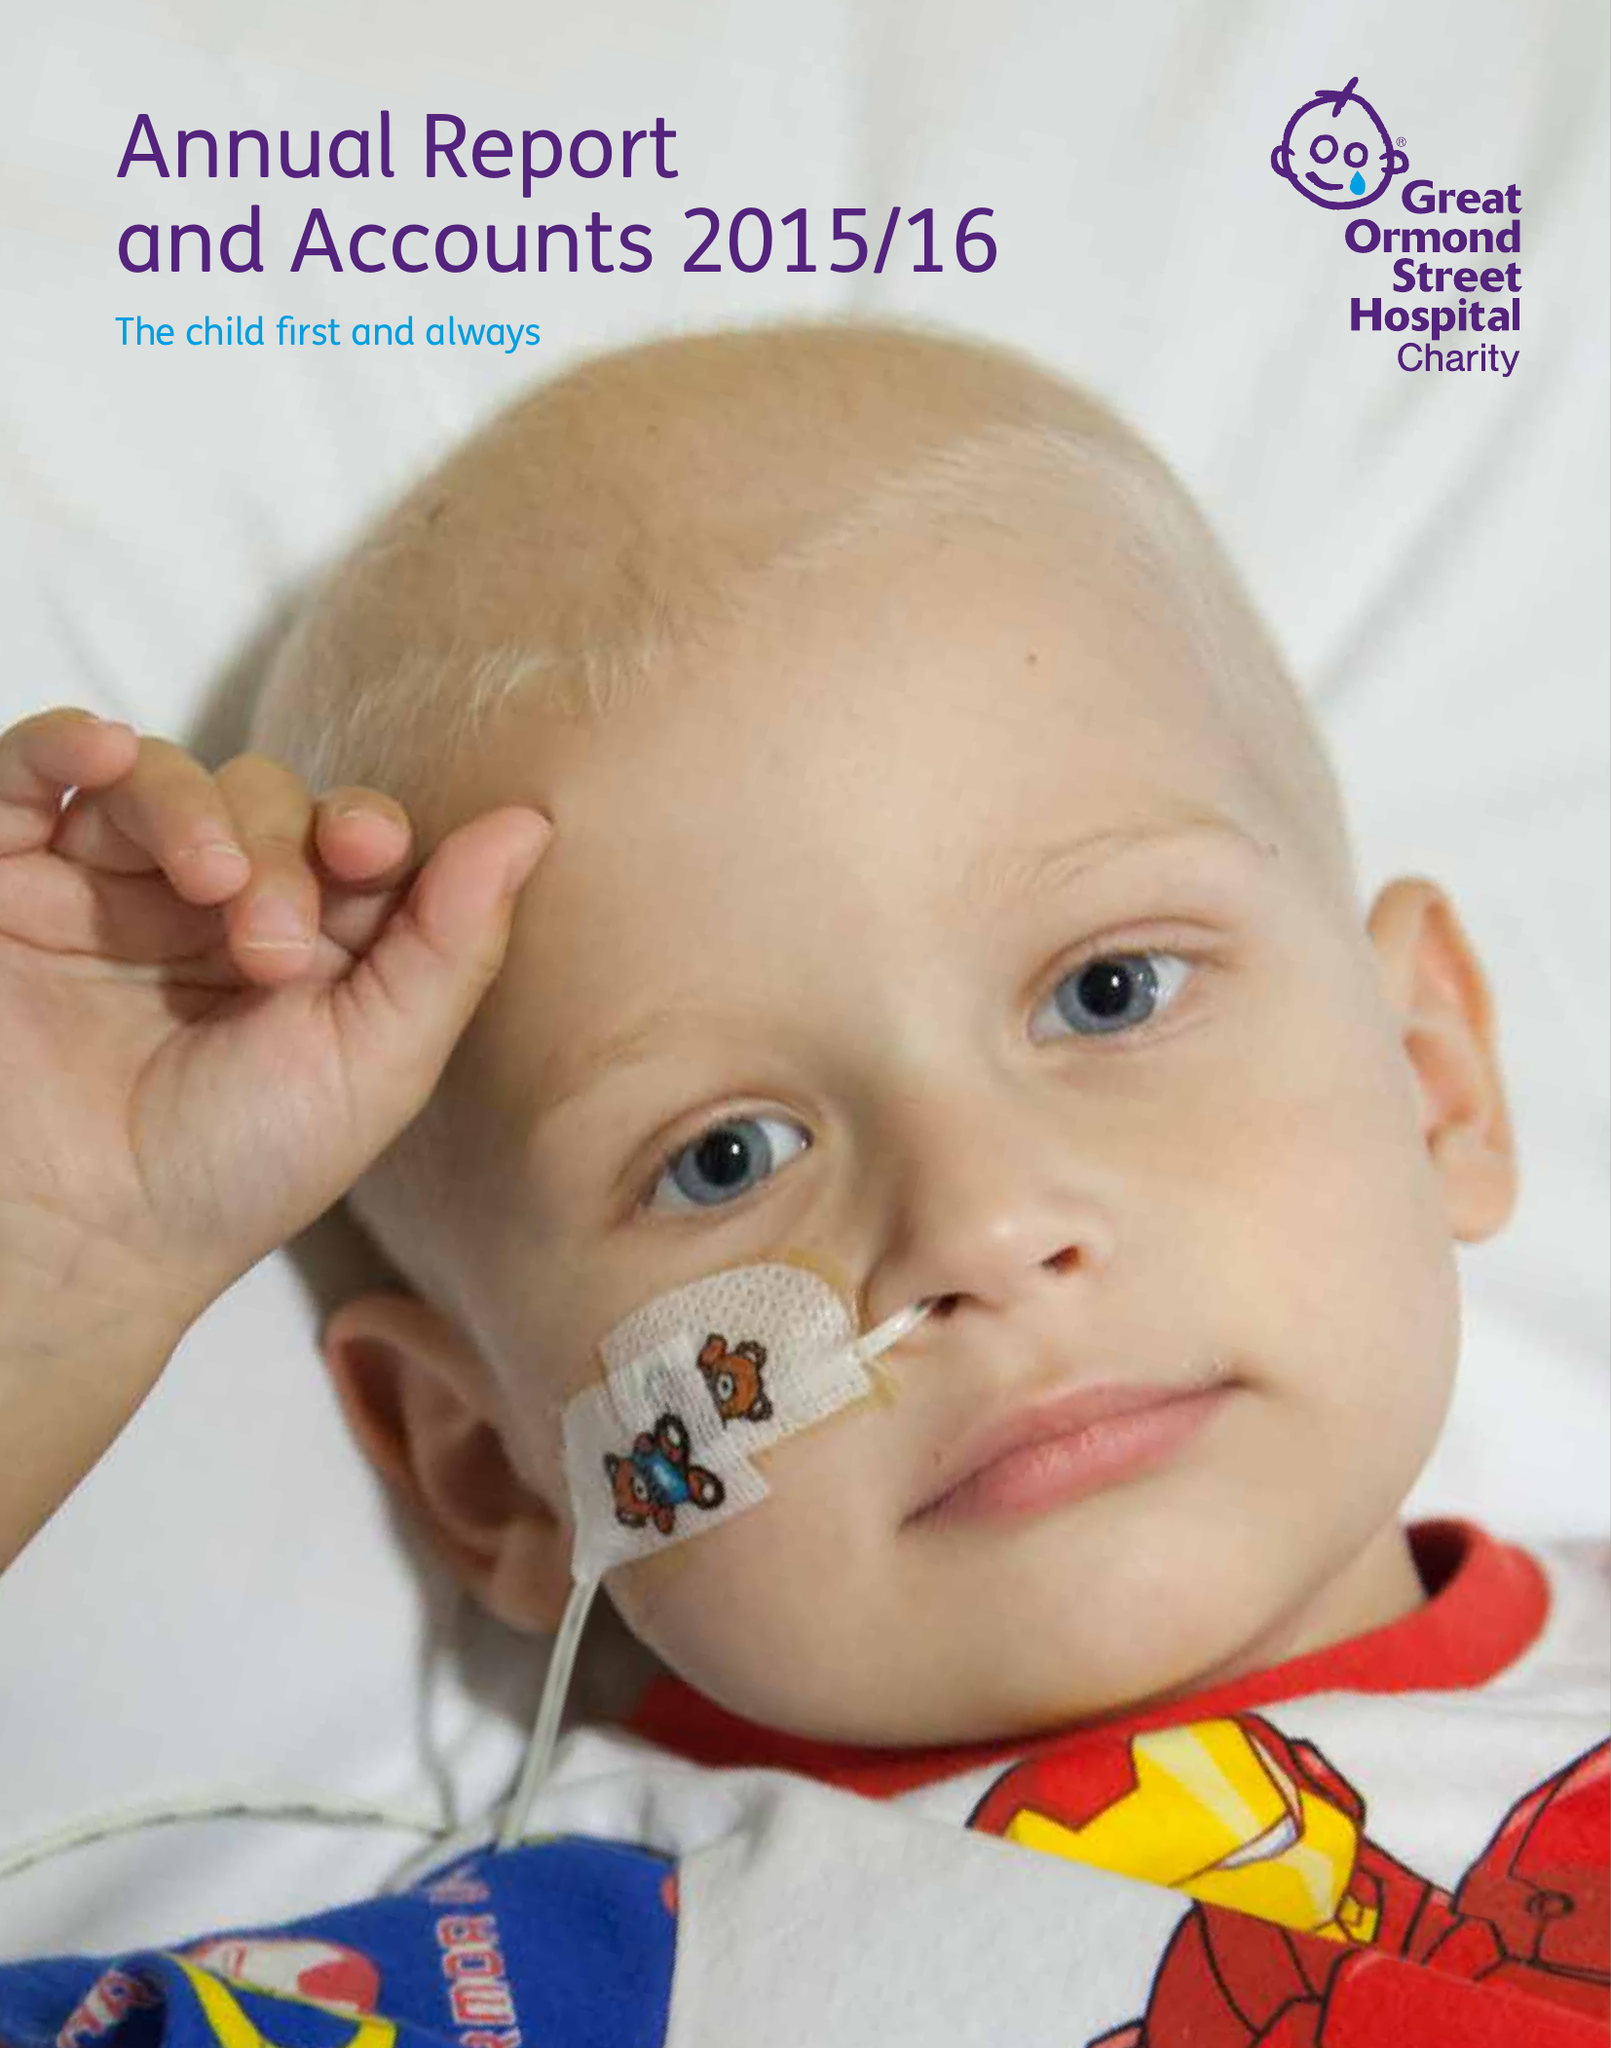What is the value for the address__street_line?
Answer the question using a single word or phrase. 40 BERNARD STREET 